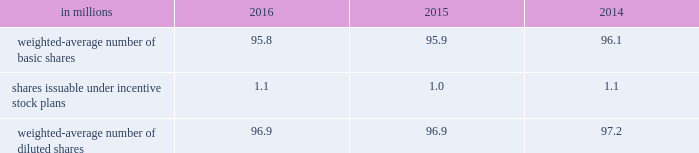The table summarizes the weighted-average number of ordinary shares outstanding for basic and diluted earnings per share calculations. .
At december 31 , 2016 , 0.6 million stock options were excluded from the computation of weighted average diluted shares outstanding because the effect of including these shares would have been anti-dilutive .
Note 21 2013 commitments and contingencies the company is involved in various litigations , claims and administrative proceedings , including those related to environmental and product warranty matters .
Amounts recorded for identified contingent liabilities are estimates , which are reviewed periodically and adjusted to reflect additional information when it becomes available .
Subject to the uncertainties inherent in estimating future costs for contingent liabilities , except as expressly set forth in this note , management believes that any liability which may result from these legal matters would not have a material adverse effect on the financial condition , results of operations , liquidity or cash flows of the company .
Environmental matters the company is dedicated to an environmental program to reduce the utilization and generation of hazardous materials during the manufacturing process and to remediate identified environmental concerns .
As to the latter , the company is currently engaged in site investigations and remediation activities to address environmental cleanup from past operations at current and former production facilities .
The company regularly evaluates its remediation programs and considers alternative remediation methods that are in addition to , or in replacement of , those currently utilized by the company based upon enhanced technology and regulatory changes .
Changes to the company's remediation programs may result in increased expenses and increased environmental reserves .
The company is sometimes a party to environmental lawsuits and claims and has received notices of potential violations of environmental laws and regulations from the u.s .
Environmental protection agency and similar state authorities .
It has also been identified as a potentially responsible party ( "prp" ) for cleanup costs associated with off-site waste disposal at federal superfund and state remediation sites .
For all such sites , there are other prps and , in most instances , the company 2019s involvement is minimal .
In estimating its liability , the company has assumed it will not bear the entire cost of remediation of any site to the exclusion of other prps who may be jointly and severally liable .
The ability of other prps to participate has been taken into account , based on our understanding of the parties 2019 financial condition and probable contributions on a per site basis .
Additional lawsuits and claims involving environmental matters are likely to arise from time to time in the future .
The company incurred $ 23.3 million , $ 4.4 million , and $ 2.9 million of expenses during the years ended december 31 , 2016 , 2015 and 2014 , respectively , for environmental remediation at sites presently or formerly owned or leased by the company .
In the fourth-quarter of 2016 , with the collaboration and approval of state regulators , the company launched a proactive , alternative approach to remediate two sites in the united states .
This approach will allow the company to more aggressively address environmental conditions at these sites and reduce the impact of potential changes in regulatory requirements .
As a result , the company recorded a $ 15 million charge for environmental remediation in the fourth quarter .
Environmental remediation costs are recorded in costs of goods sold within the consolidated statements of comprehensive income .
As of december 31 , 2016 and 2015 , the company has recorded reserves for environmental matters of $ 30.6 million and $ 15.2 million .
The total reserve at december 31 , 2016 and 2015 included $ 9.6 million and $ 2.8 million related to remediation of sites previously disposed by the company .
Environmental reserves are classified as accrued expenses and other current liabilities or other noncurrent liabilities based on their expected term .
The company's total current environmental reserve at december 31 , 2016 and 2015 was $ 6.1 million and $ 3.7 million and the remainder is classified as noncurrent .
Given the evolving nature of environmental laws , regulations and technology , the ultimate cost of future compliance is uncertain .
Warranty liability standard product warranty accruals are recorded at the time of sale and are estimated based upon product warranty terms and historical experience .
The company assesses the adequacy of its liabilities and will make adjustments as necessary based on known or anticipated warranty claims , or as new information becomes available. .
Considering the years 2014-2016 , what is the average number of shares issuable under incentive stock plans , in millions? 
Rationale: it is the sum of all shares issuable under incentive stock plans during these years , then divided by three .
Computations: table_average(shares issuable under incentive stock plans, none)
Answer: 1.06667. 